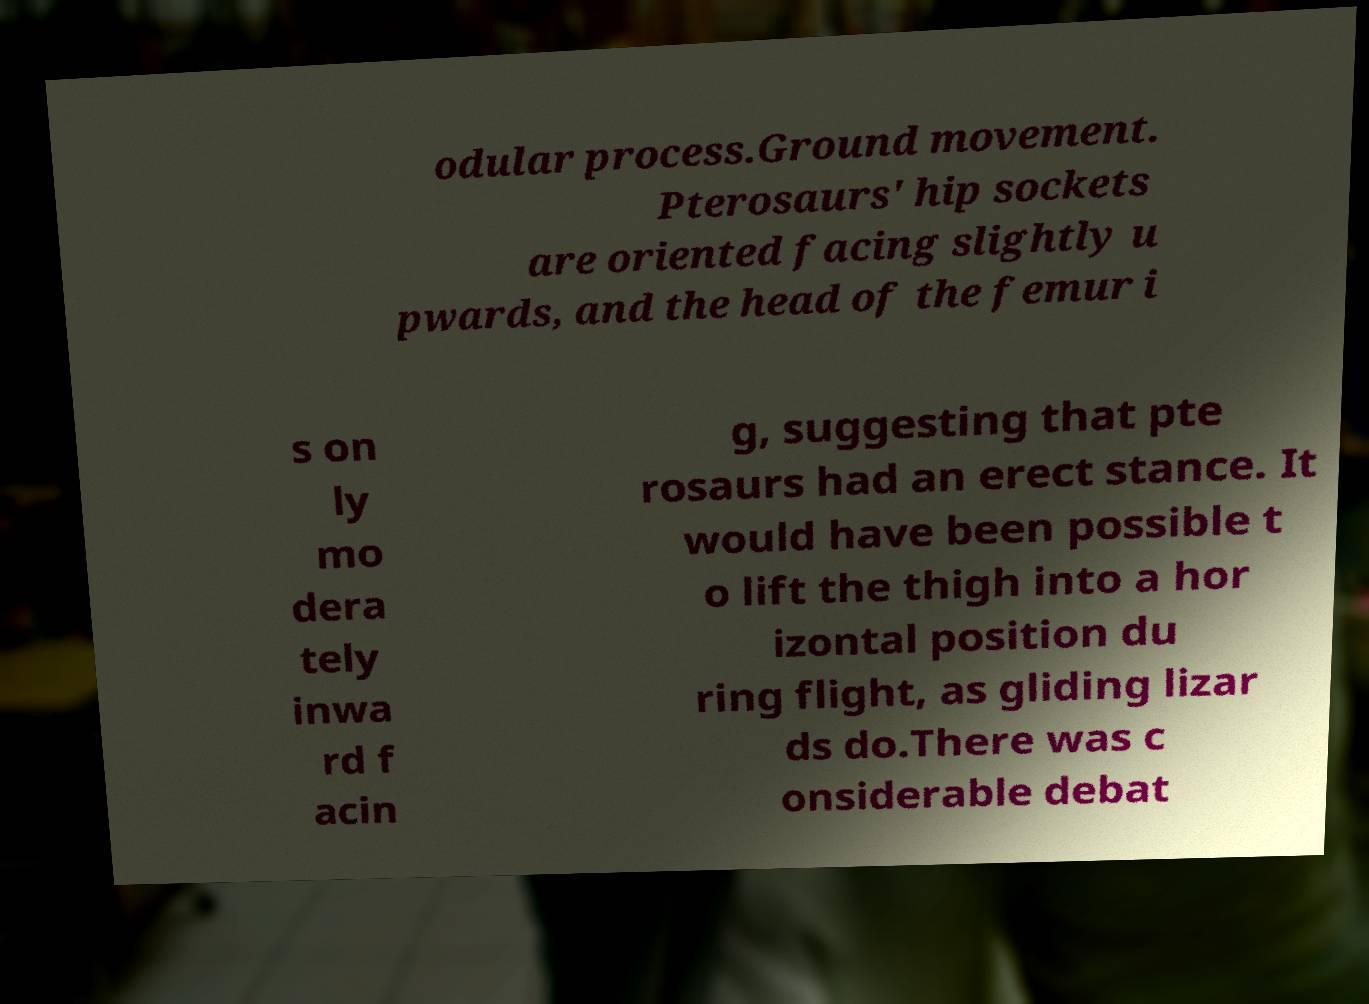Please read and relay the text visible in this image. What does it say? odular process.Ground movement. Pterosaurs' hip sockets are oriented facing slightly u pwards, and the head of the femur i s on ly mo dera tely inwa rd f acin g, suggesting that pte rosaurs had an erect stance. It would have been possible t o lift the thigh into a hor izontal position du ring flight, as gliding lizar ds do.There was c onsiderable debat 